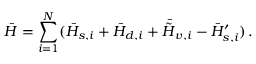<formula> <loc_0><loc_0><loc_500><loc_500>\bar { H } = \sum _ { i = 1 } ^ { N } ( \bar { H } _ { s , i } + \bar { H } _ { d , i } + \bar { \tilde { H } } _ { v , i } - \bar { H } _ { s , i } ^ { \prime } ) \, .</formula> 